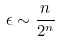Convert formula to latex. <formula><loc_0><loc_0><loc_500><loc_500>\epsilon \sim \frac { n } { 2 ^ { n } }</formula> 